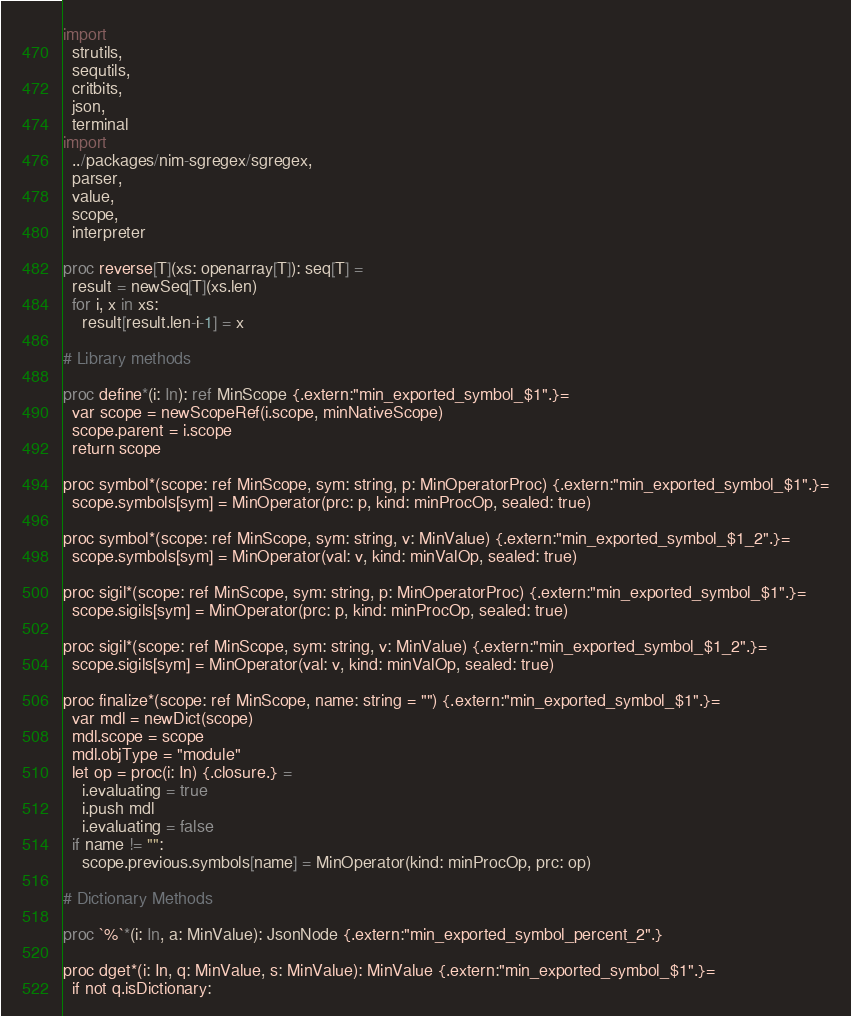Convert code to text. <code><loc_0><loc_0><loc_500><loc_500><_Nim_>import 
  strutils, 
  sequtils,
  critbits,
  json,
  terminal
import 
  ../packages/nim-sgregex/sgregex,
  parser, 
  value,
  scope,
  interpreter

proc reverse[T](xs: openarray[T]): seq[T] =
  result = newSeq[T](xs.len)
  for i, x in xs:
    result[result.len-i-1] = x 

# Library methods

proc define*(i: In): ref MinScope {.extern:"min_exported_symbol_$1".}=
  var scope = newScopeRef(i.scope, minNativeScope)
  scope.parent = i.scope
  return scope

proc symbol*(scope: ref MinScope, sym: string, p: MinOperatorProc) {.extern:"min_exported_symbol_$1".}=
  scope.symbols[sym] = MinOperator(prc: p, kind: minProcOp, sealed: true)

proc symbol*(scope: ref MinScope, sym: string, v: MinValue) {.extern:"min_exported_symbol_$1_2".}=
  scope.symbols[sym] = MinOperator(val: v, kind: minValOp, sealed: true)

proc sigil*(scope: ref MinScope, sym: string, p: MinOperatorProc) {.extern:"min_exported_symbol_$1".}=
  scope.sigils[sym] = MinOperator(prc: p, kind: minProcOp, sealed: true)

proc sigil*(scope: ref MinScope, sym: string, v: MinValue) {.extern:"min_exported_symbol_$1_2".}=
  scope.sigils[sym] = MinOperator(val: v, kind: minValOp, sealed: true)

proc finalize*(scope: ref MinScope, name: string = "") {.extern:"min_exported_symbol_$1".}=
  var mdl = newDict(scope)
  mdl.scope = scope
  mdl.objType = "module"
  let op = proc(i: In) {.closure.} =
    i.evaluating = true
    i.push mdl
    i.evaluating = false
  if name != "":
    scope.previous.symbols[name] = MinOperator(kind: minProcOp, prc: op)

# Dictionary Methods

proc `%`*(i: In, a: MinValue): JsonNode {.extern:"min_exported_symbol_percent_2".}

proc dget*(i: In, q: MinValue, s: MinValue): MinValue {.extern:"min_exported_symbol_$1".}=
  if not q.isDictionary:</code> 